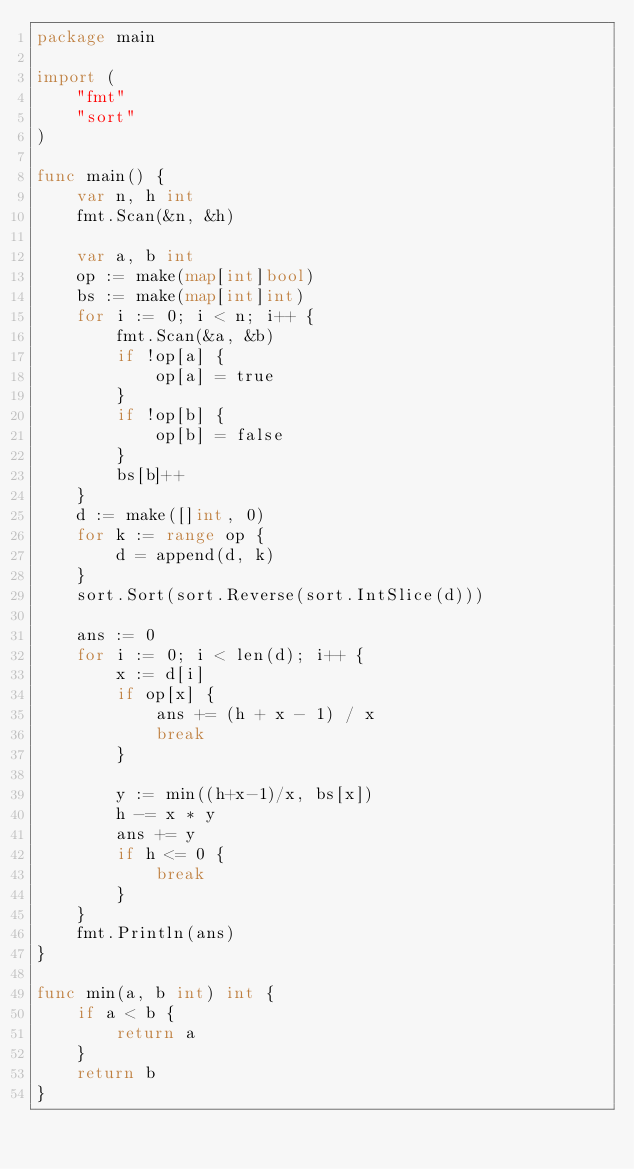<code> <loc_0><loc_0><loc_500><loc_500><_Go_>package main

import (
	"fmt"
	"sort"
)

func main() {
	var n, h int
	fmt.Scan(&n, &h)

	var a, b int
	op := make(map[int]bool)
	bs := make(map[int]int)
	for i := 0; i < n; i++ {
		fmt.Scan(&a, &b)
		if !op[a] {
			op[a] = true
		}
		if !op[b] {
			op[b] = false
		}
		bs[b]++
	}
	d := make([]int, 0)
	for k := range op {
		d = append(d, k)
	}
	sort.Sort(sort.Reverse(sort.IntSlice(d)))

	ans := 0
	for i := 0; i < len(d); i++ {
		x := d[i]
		if op[x] {
			ans += (h + x - 1) / x
			break
		}

		y := min((h+x-1)/x, bs[x])
		h -= x * y
		ans += y
		if h <= 0 {
			break
		}
	}
	fmt.Println(ans)
}

func min(a, b int) int {
	if a < b {
		return a
	}
	return b
}
</code> 